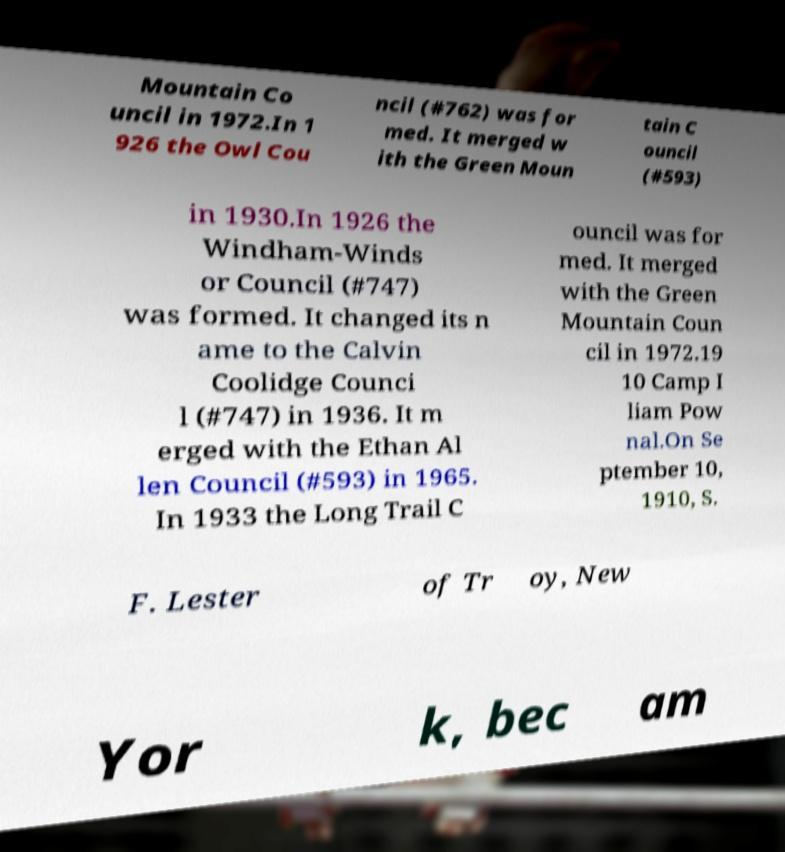For documentation purposes, I need the text within this image transcribed. Could you provide that? Mountain Co uncil in 1972.In 1 926 the Owl Cou ncil (#762) was for med. It merged w ith the Green Moun tain C ouncil (#593) in 1930.In 1926 the Windham-Winds or Council (#747) was formed. It changed its n ame to the Calvin Coolidge Counci l (#747) in 1936. It m erged with the Ethan Al len Council (#593) in 1965. In 1933 the Long Trail C ouncil was for med. It merged with the Green Mountain Coun cil in 1972.19 10 Camp I liam Pow nal.On Se ptember 10, 1910, S. F. Lester of Tr oy, New Yor k, bec am 